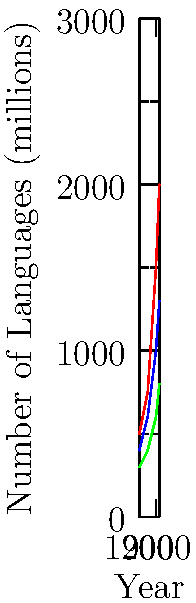Based on the graph showing the spread of major languages from 1900 to 2020, which language has experienced the most significant relative growth, and what historical factors might explain this trend? To answer this question, we need to analyze the relative growth of each language:

1. Calculate the growth factor for each language from 1900 to 2020:
   - English: 2000 / 500 = 4
   - Mandarin: 1300 / 400 = 3.25
   - Spanish: 800 / 300 = 2.67

2. English has the highest growth factor, indicating the most significant relative growth.

3. Historical factors explaining this trend:
   a) British colonialism: Established English in many parts of the world.
   b) Rise of the United States as a global superpower post-World War II.
   c) Globalization of media and popular culture, often dominated by English-language content.
   d) Internet revolution: English became the dominant language of the web.
   e) International business and diplomacy increasingly conducted in English.
   f) English as the primary language of scientific publications and academic discourse.

4. The steeper curve for English, especially post-1950, aligns with these historical developments.

5. While Mandarin and Spanish have also grown, their growth has been less pronounced, likely due to more regional influence compared to English's global reach.
Answer: English; due to colonialism, US influence, and globalization. 